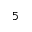<formula> <loc_0><loc_0><loc_500><loc_500>5</formula> 